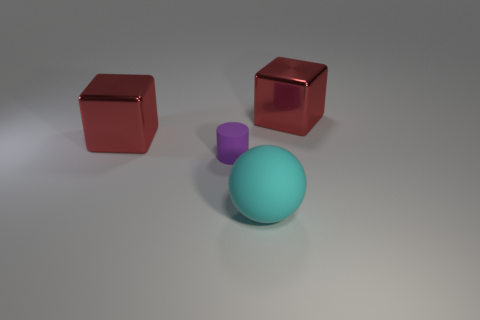Add 4 purple matte cylinders. How many objects exist? 8 Subtract all spheres. How many objects are left? 3 Add 1 tiny purple cubes. How many tiny purple cubes exist? 1 Subtract 0 red cylinders. How many objects are left? 4 Subtract all cubes. Subtract all small matte cylinders. How many objects are left? 1 Add 1 small cylinders. How many small cylinders are left? 2 